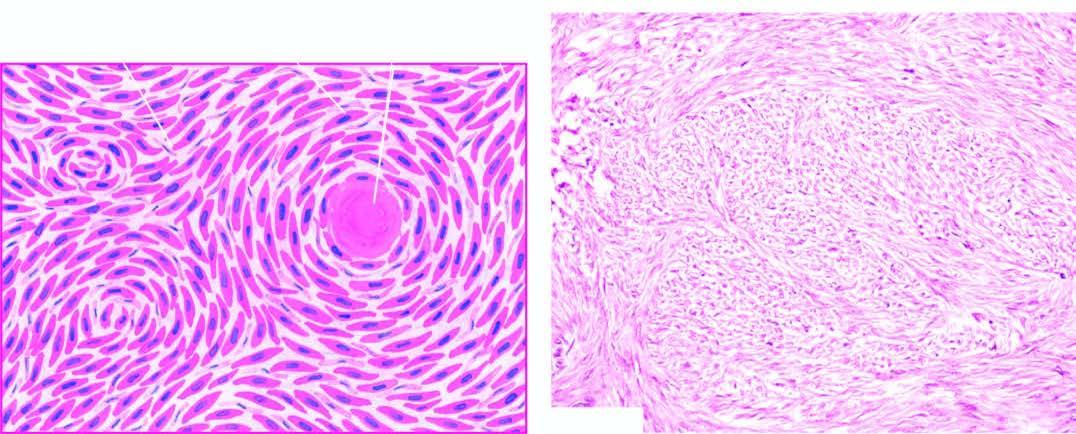what shows whorls of smooth muscle cells which are spindle-shaped, having abundant cytoplasm and oval nuclei?
Answer the question using a single word or phrase. Microscopy 